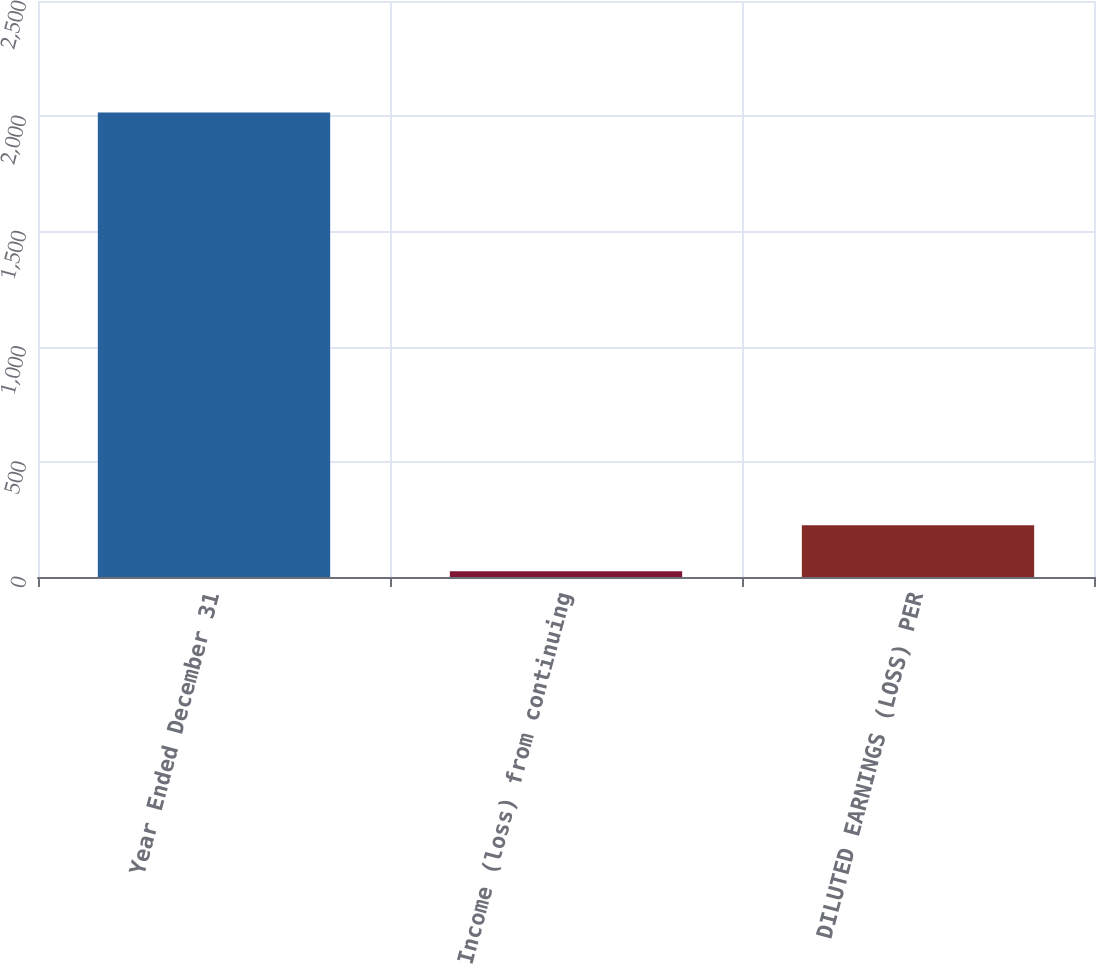<chart> <loc_0><loc_0><loc_500><loc_500><bar_chart><fcel>Year Ended December 31<fcel>Income (loss) from continuing<fcel>DILUTED EARNINGS (LOSS) PER<nl><fcel>2016<fcel>25<fcel>224.1<nl></chart> 